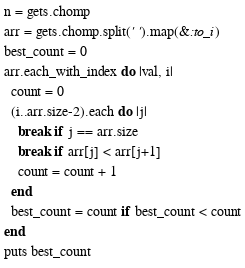<code> <loc_0><loc_0><loc_500><loc_500><_Ruby_>n = gets.chomp
arr = gets.chomp.split(' ').map(&:to_i)
best_count = 0
arr.each_with_index do |val, i|
  count = 0
  (i..arr.size-2).each do |j|
    break if j == arr.size
    break if arr[j] < arr[j+1]
    count = count + 1
  end
  best_count = count if best_count < count
end
puts best_count</code> 